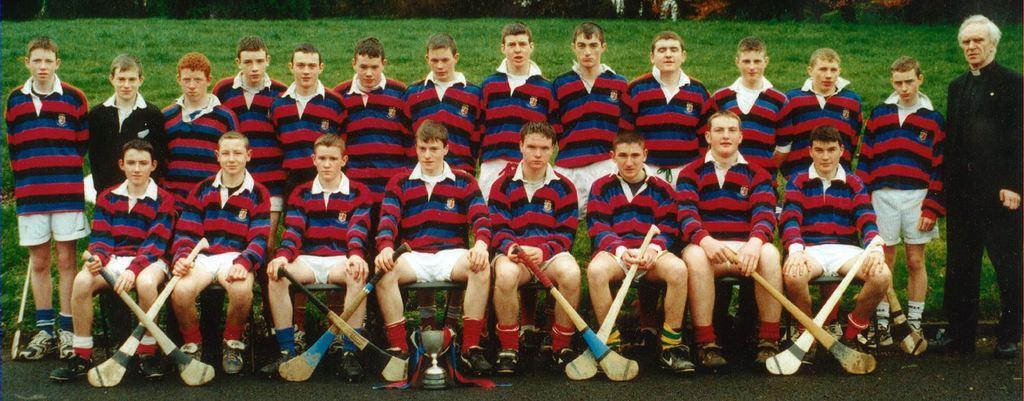Describe this image in one or two sentences. In this image we can see a group of people on a grassy land. 